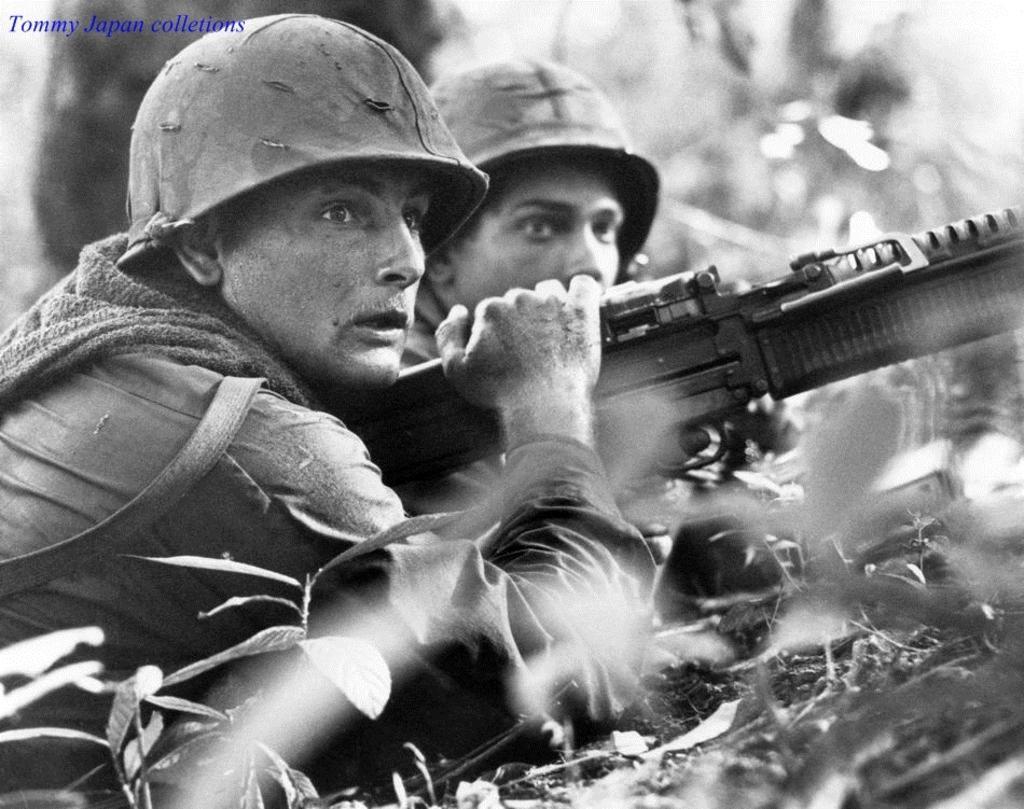Please provide a concise description of this image. In this image I can see two persons. The person in front holding a gun and the image is in black and white. 